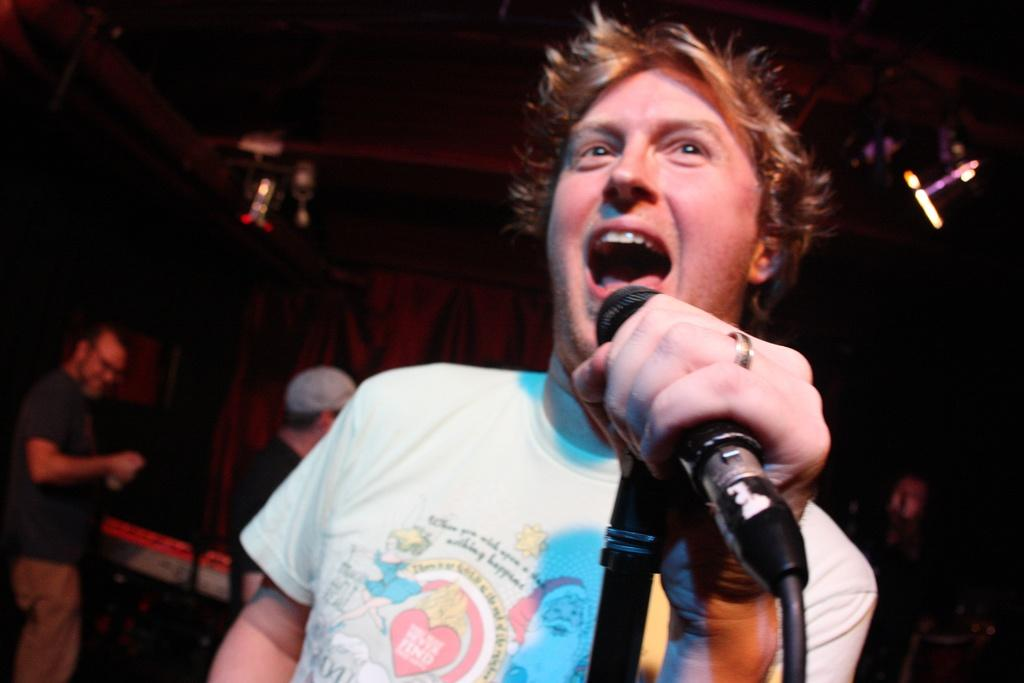What is the man in the image doing? The man is singing a song in the club. Are there any other people present in the image? Yes, there are two persons standing behind the man. What can be seen on the roof near the man? There are lights on the roof to the man's right side. What is visible in the background of the image? There is a curtain in the background. What type of pies can be seen on the stage in the image? There are no pies present in the image; it features a man singing in a club. How many clovers are visible on the curtain in the background? There is no mention of clovers in the image, and the curtain is not described in enough detail to determine if any clovers are present. 